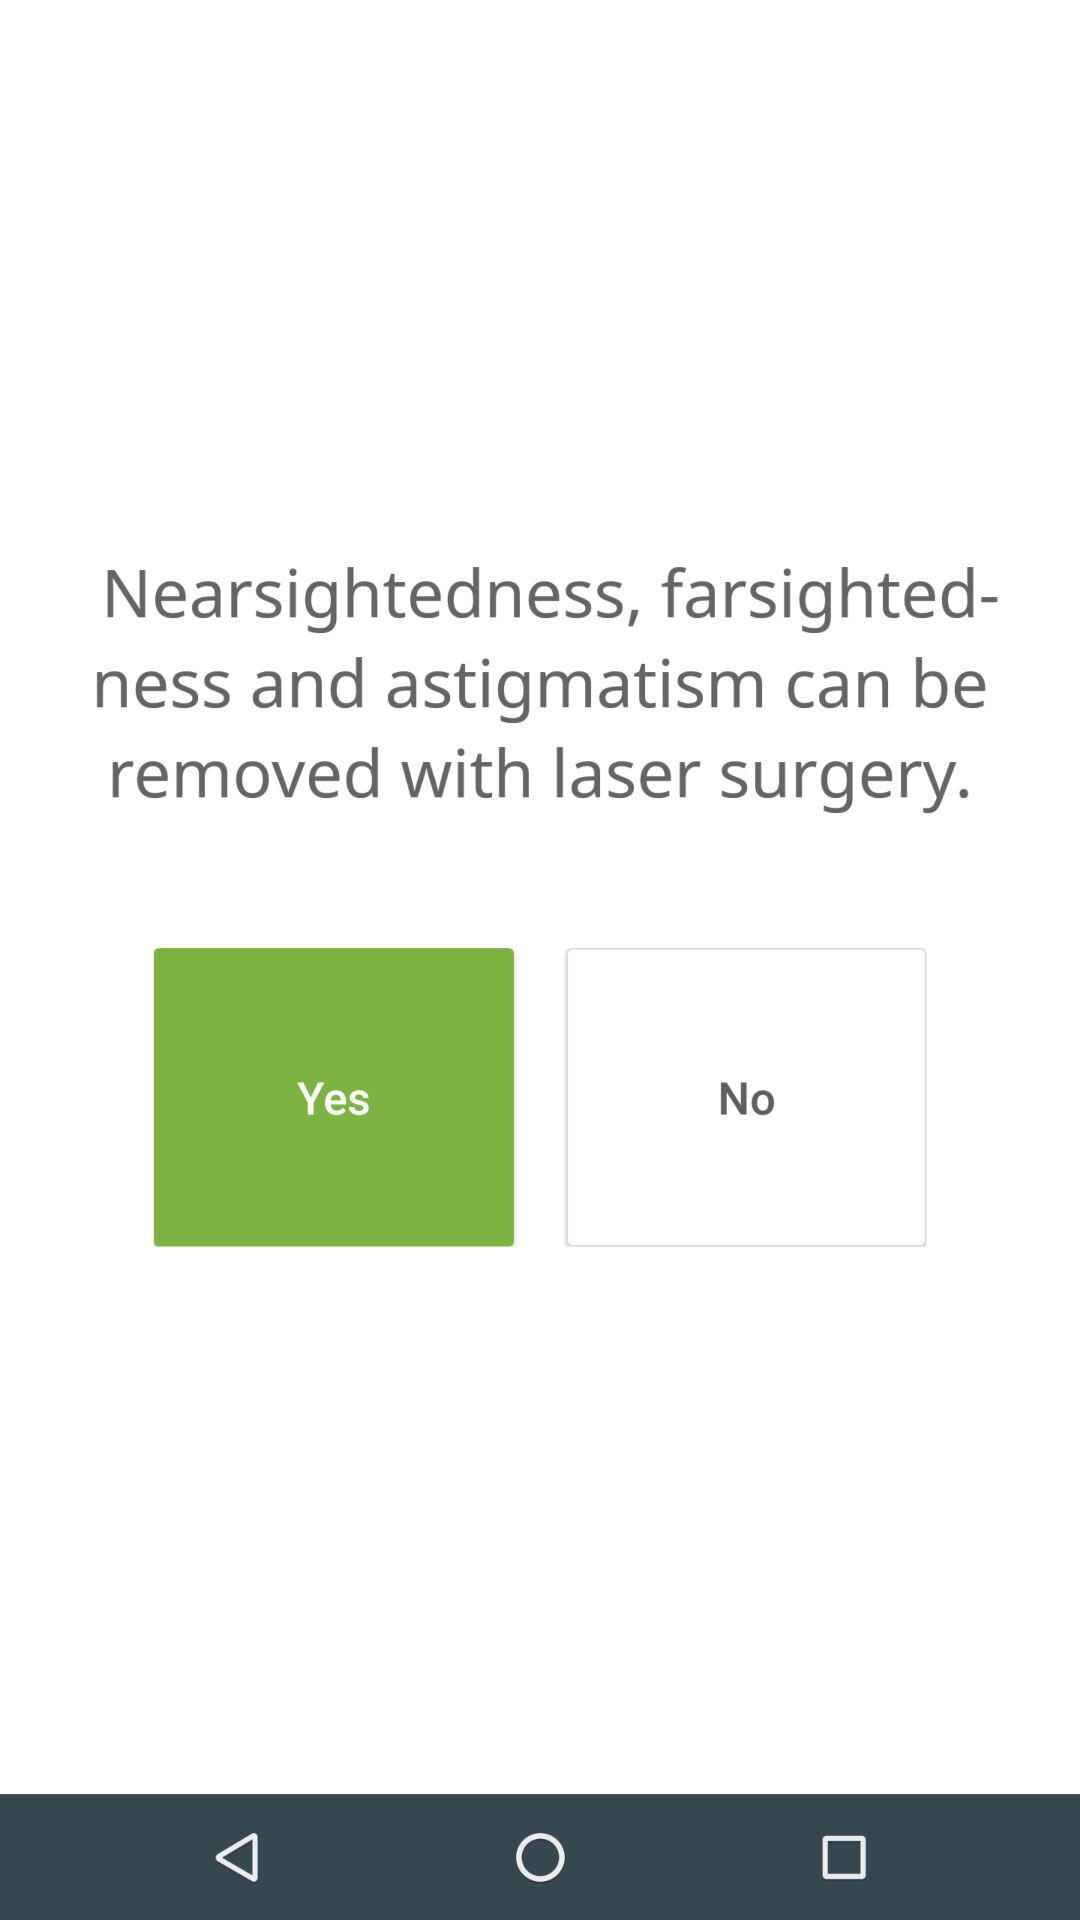Which is selected option?
When the provided information is insufficient, respond with <no answer>. <no answer> 